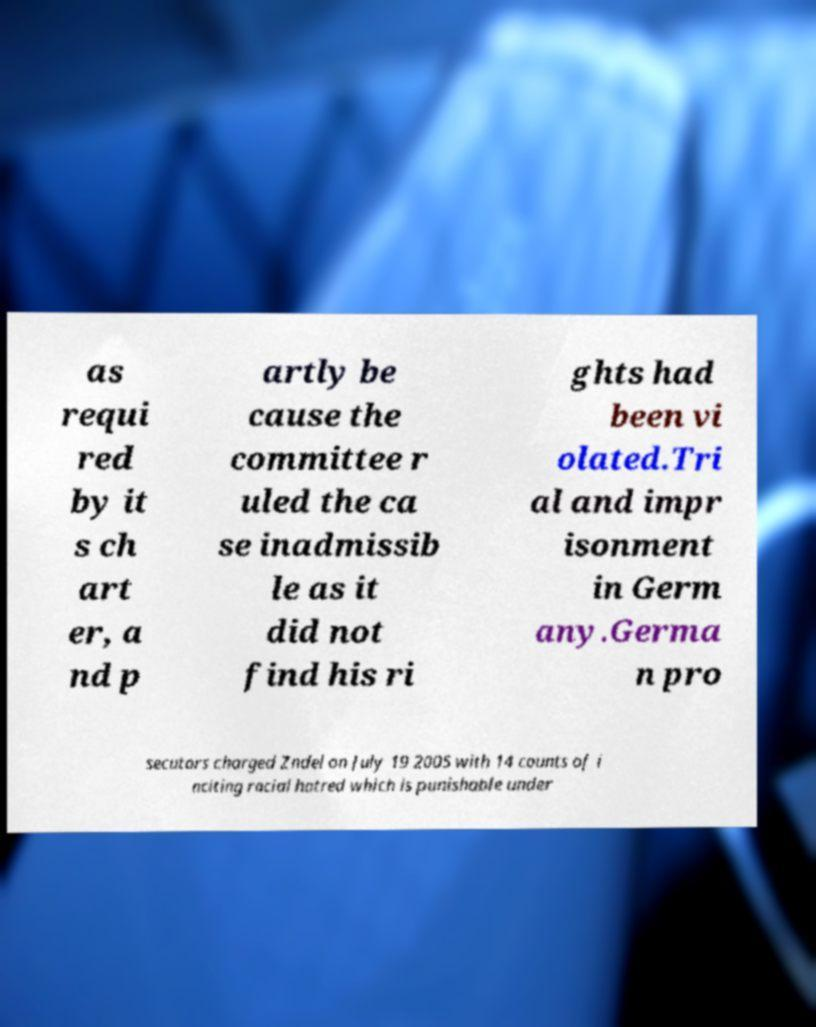I need the written content from this picture converted into text. Can you do that? as requi red by it s ch art er, a nd p artly be cause the committee r uled the ca se inadmissib le as it did not find his ri ghts had been vi olated.Tri al and impr isonment in Germ any.Germa n pro secutors charged Zndel on July 19 2005 with 14 counts of i nciting racial hatred which is punishable under 